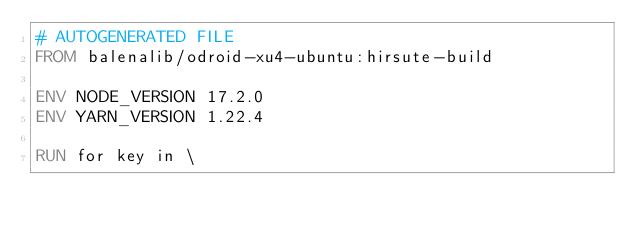Convert code to text. <code><loc_0><loc_0><loc_500><loc_500><_Dockerfile_># AUTOGENERATED FILE
FROM balenalib/odroid-xu4-ubuntu:hirsute-build

ENV NODE_VERSION 17.2.0
ENV YARN_VERSION 1.22.4

RUN for key in \</code> 